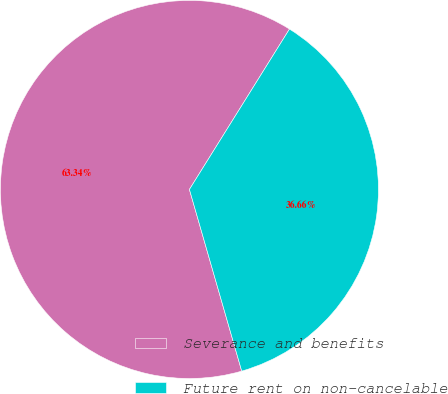Convert chart to OTSL. <chart><loc_0><loc_0><loc_500><loc_500><pie_chart><fcel>Severance and benefits<fcel>Future rent on non-cancelable<nl><fcel>63.34%<fcel>36.66%<nl></chart> 